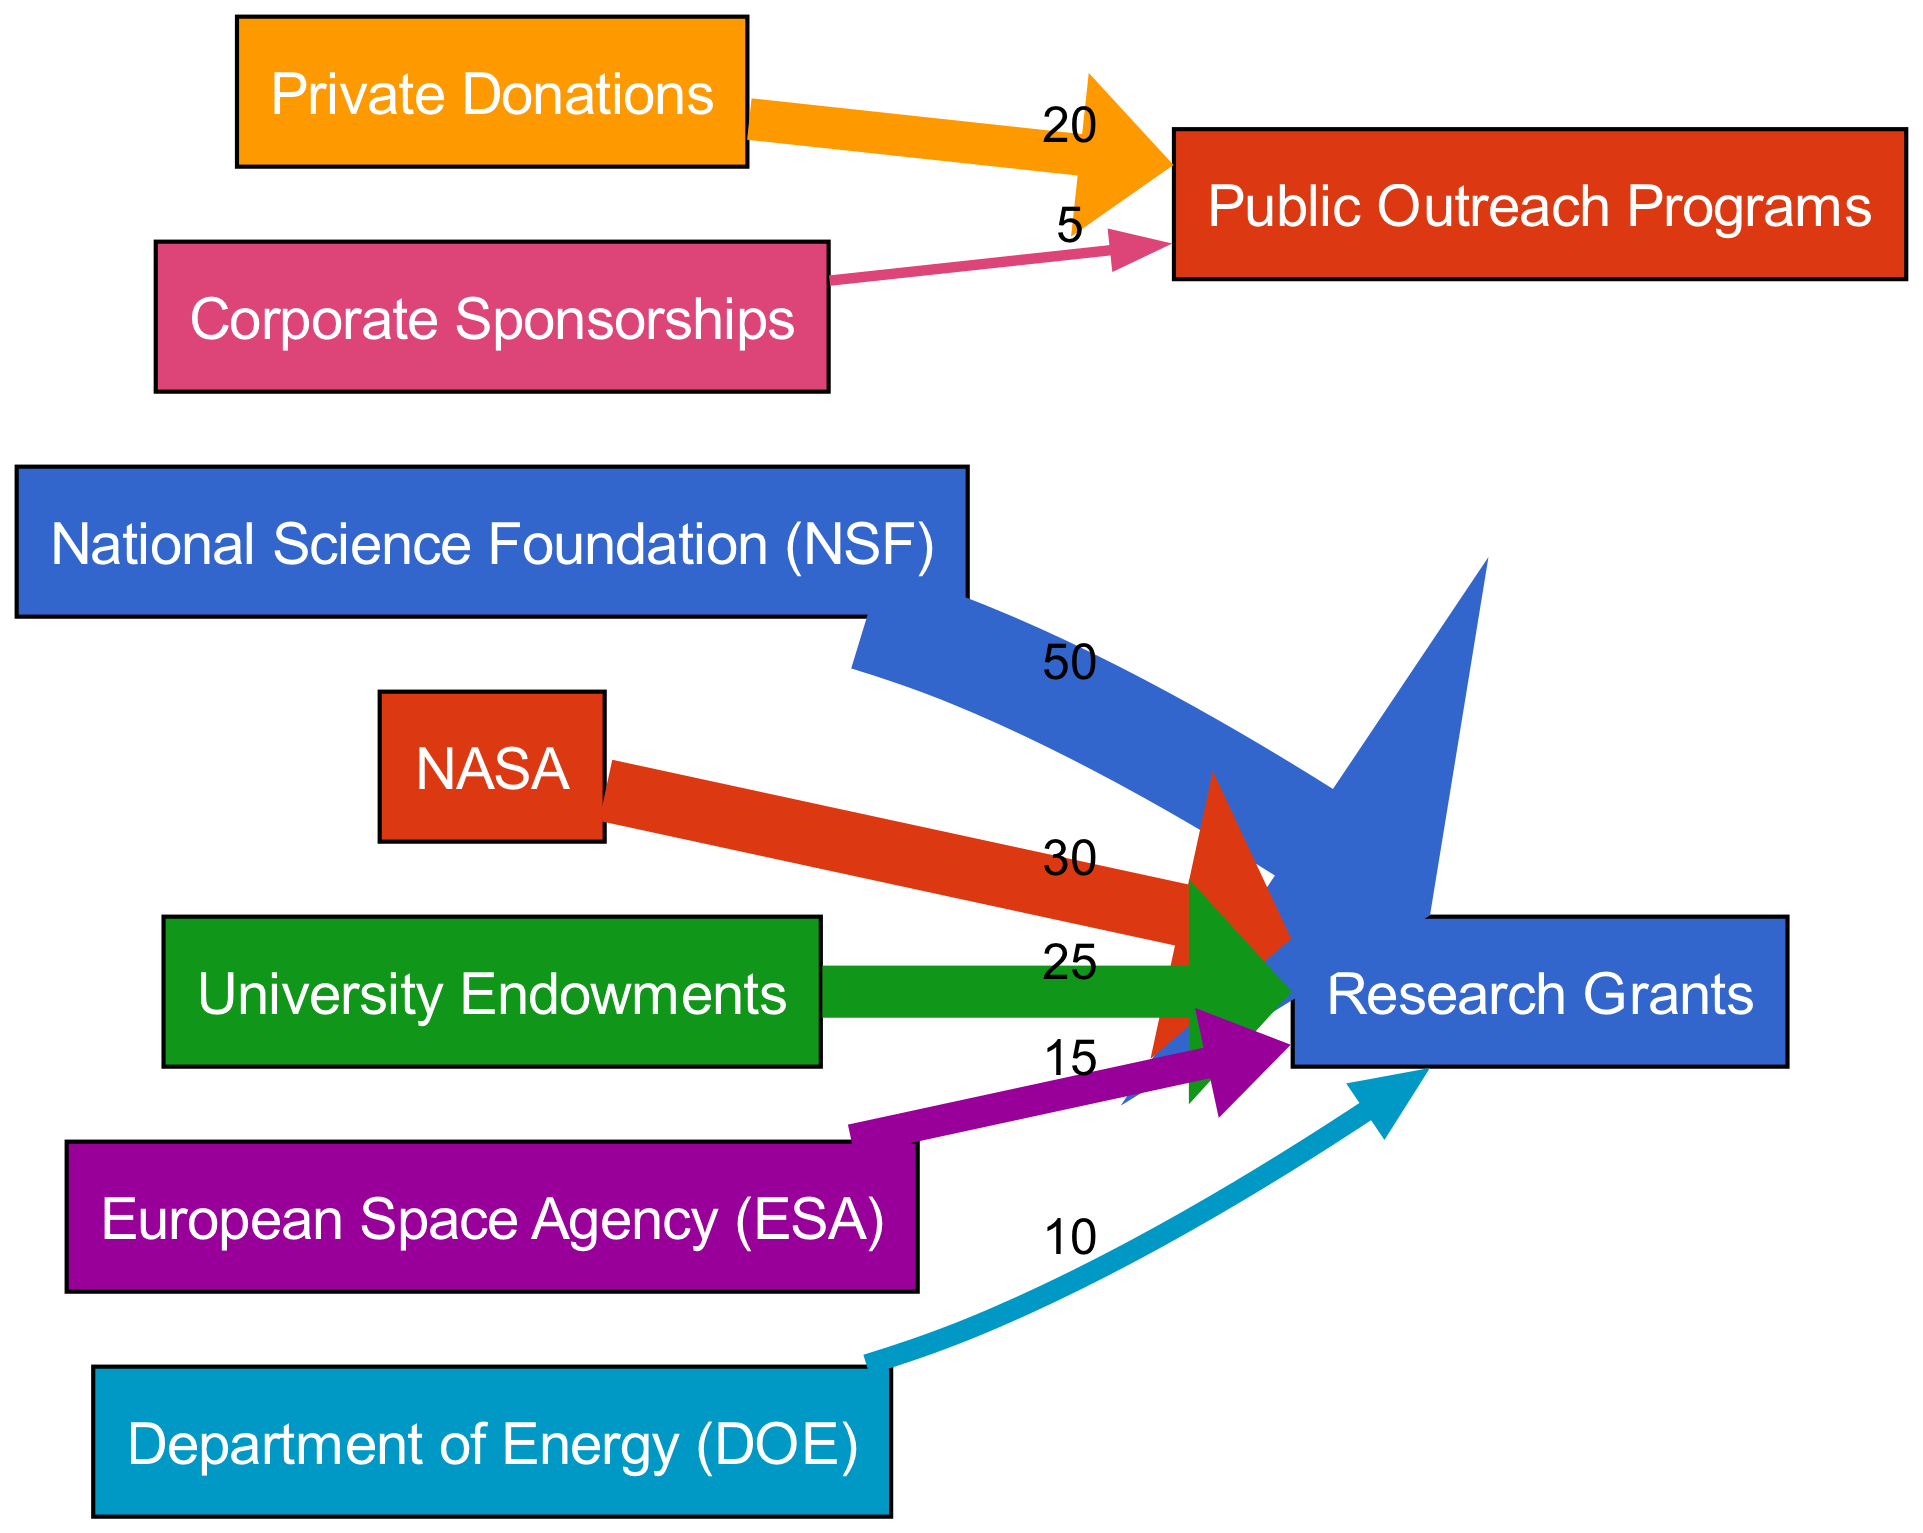What is the total value flowing into Research Grants? The total value flowing into Research Grants can be calculated by summing the values from all sources that contribute to it: 50 (NSF) + 30 (NASA) + 25 (University Endowments) + 15 (ESA) + 10 (DOE) = 130.
Answer: 130 How much funding comes from Private Donations? Private Donations contribute a value of 20, which is specifically directed towards Public Outreach Programs. The diagram shows no other contributions from this source.
Answer: 20 Which source has the least contribution towards Public Outreach Programs? The source with the least contribution is Corporate Sponsorships, which has a value of 5 directed towards Public Outreach Programs, as no other source contributes to it.
Answer: Corporate Sponsorships What percentage of the total Research Grants comes from the National Science Foundation? The National Science Foundation contributes 50 towards Research Grants. The total for Research Grants is 130. To find the percentage: (50 / 130) * 100 = 38.46%, approximately 38%.
Answer: 38% How many edges are in the diagram? The number of edges in the diagram represents the number of links between nodes, which is evident from the links data. There are 7 links in total.
Answer: 7 Which funding source provides the highest contribution to Research Grants? The National Science Foundation provides the highest contribution to Research Grants, with a total of 50. This is the highest individual value in the flow diagram directed into Research Grants.
Answer: National Science Foundation (NSF) What is the flow value from NASA to Research Grants? The flow value from NASA to Research Grants is specified as 30 in the diagram, which directly connects these two nodes.
Answer: 30 What is the total amount of funding for Public Outreach Programs? Public Outreach Programs receive funding from Private Donations (20) and Corporate Sponsorships (5). Therefore, the total amount is 20 + 5 = 25.
Answer: 25 What type of analysis does this Sankey Diagram illustrate? This Sankey Diagram illustrates the breakdown of different funding sources for astrophysics research, showcasing the flow of funds from various contributors to designated uses, indicating how grants and donations are allocated.
Answer: Breakdown of funding sources 